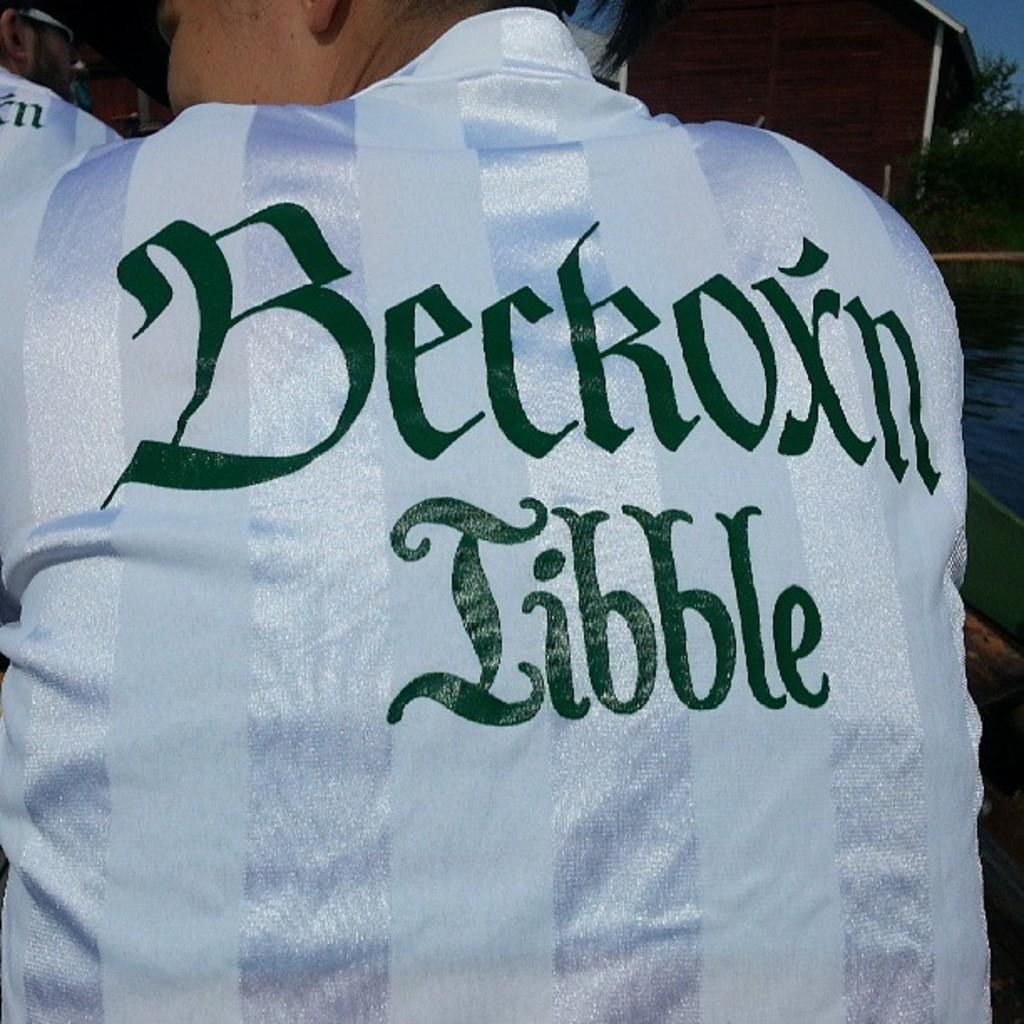<image>
Share a concise interpretation of the image provided. The guy is wearing a jersey that has the name Beckoxn on it. 